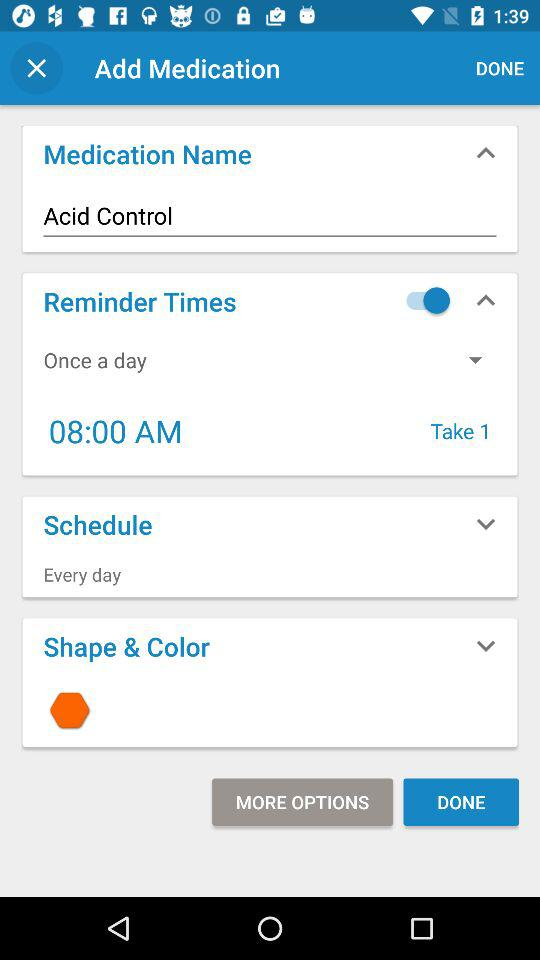What's the status of "Reminder Times"? The status is "on". 